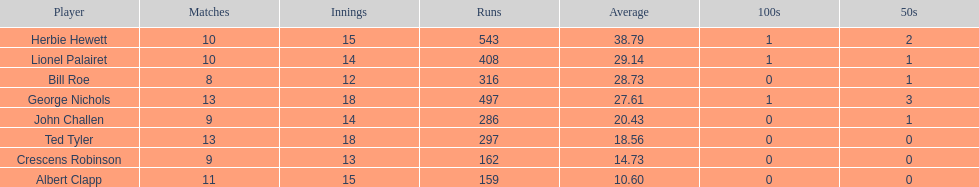What is the minimum number of runs someone has? 159. 